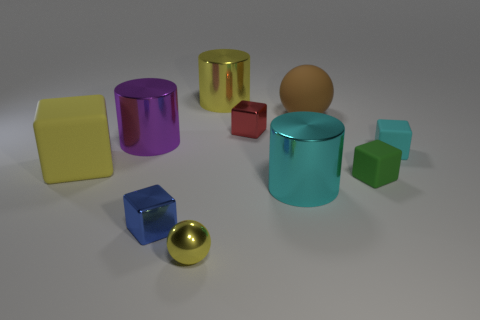Subtract all yellow cubes. How many cubes are left? 4 Subtract all big matte cubes. How many cubes are left? 4 Subtract all brown blocks. Subtract all red spheres. How many blocks are left? 5 Subtract all spheres. How many objects are left? 8 Subtract all big blue metal cubes. Subtract all yellow metallic things. How many objects are left? 8 Add 5 yellow objects. How many yellow objects are left? 8 Add 2 large gray matte cylinders. How many large gray matte cylinders exist? 2 Subtract 0 blue spheres. How many objects are left? 10 